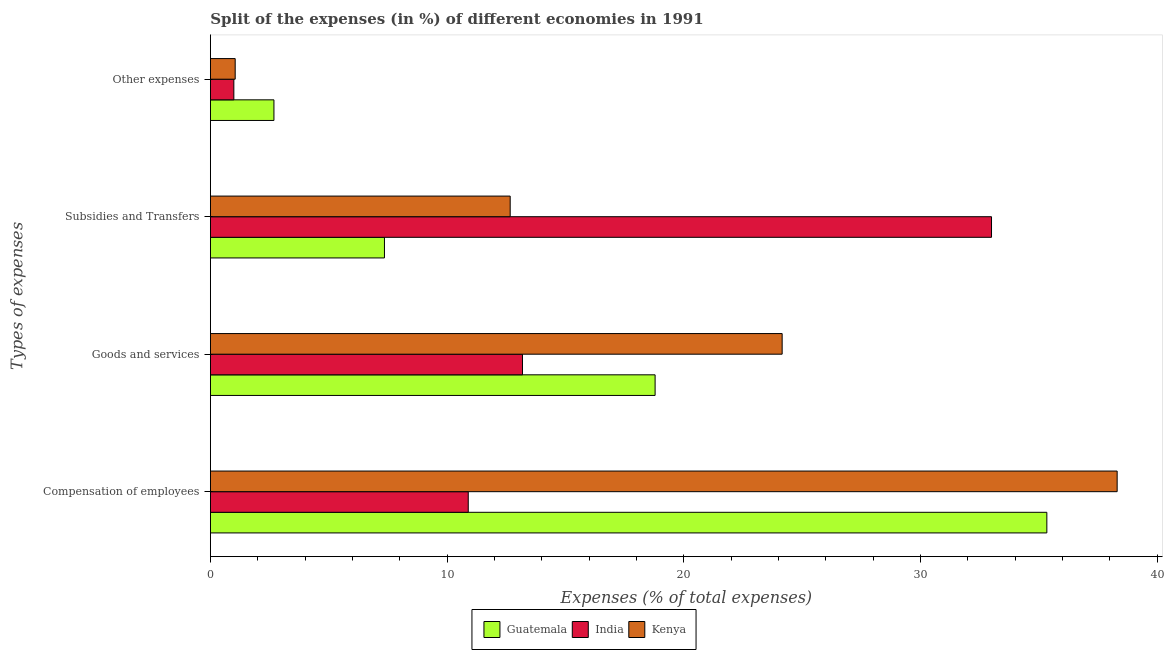Are the number of bars per tick equal to the number of legend labels?
Give a very brief answer. Yes. How many bars are there on the 3rd tick from the bottom?
Offer a very short reply. 3. What is the label of the 3rd group of bars from the top?
Provide a succinct answer. Goods and services. What is the percentage of amount spent on other expenses in India?
Offer a terse response. 0.99. Across all countries, what is the maximum percentage of amount spent on compensation of employees?
Your answer should be compact. 38.32. Across all countries, what is the minimum percentage of amount spent on goods and services?
Provide a succinct answer. 13.19. In which country was the percentage of amount spent on goods and services maximum?
Keep it short and to the point. Kenya. In which country was the percentage of amount spent on goods and services minimum?
Offer a very short reply. India. What is the total percentage of amount spent on other expenses in the graph?
Ensure brevity in your answer.  4.72. What is the difference between the percentage of amount spent on compensation of employees in Kenya and that in India?
Ensure brevity in your answer.  27.42. What is the difference between the percentage of amount spent on subsidies in Guatemala and the percentage of amount spent on other expenses in India?
Offer a very short reply. 6.36. What is the average percentage of amount spent on compensation of employees per country?
Provide a succinct answer. 28.19. What is the difference between the percentage of amount spent on goods and services and percentage of amount spent on compensation of employees in India?
Your response must be concise. 2.29. In how many countries, is the percentage of amount spent on compensation of employees greater than 10 %?
Give a very brief answer. 3. What is the ratio of the percentage of amount spent on goods and services in Kenya to that in India?
Make the answer very short. 1.83. Is the percentage of amount spent on goods and services in India less than that in Kenya?
Your response must be concise. Yes. What is the difference between the highest and the second highest percentage of amount spent on other expenses?
Your answer should be very brief. 1.64. What is the difference between the highest and the lowest percentage of amount spent on other expenses?
Ensure brevity in your answer.  1.69. Is it the case that in every country, the sum of the percentage of amount spent on goods and services and percentage of amount spent on subsidies is greater than the sum of percentage of amount spent on compensation of employees and percentage of amount spent on other expenses?
Provide a succinct answer. No. What does the 2nd bar from the top in Compensation of employees represents?
Make the answer very short. India. What does the 1st bar from the bottom in Other expenses represents?
Provide a succinct answer. Guatemala. How many countries are there in the graph?
Your answer should be very brief. 3. What is the difference between two consecutive major ticks on the X-axis?
Provide a short and direct response. 10. Are the values on the major ticks of X-axis written in scientific E-notation?
Ensure brevity in your answer.  No. How many legend labels are there?
Your answer should be very brief. 3. How are the legend labels stacked?
Keep it short and to the point. Horizontal. What is the title of the graph?
Offer a very short reply. Split of the expenses (in %) of different economies in 1991. Does "Lesotho" appear as one of the legend labels in the graph?
Make the answer very short. No. What is the label or title of the X-axis?
Ensure brevity in your answer.  Expenses (% of total expenses). What is the label or title of the Y-axis?
Your answer should be compact. Types of expenses. What is the Expenses (% of total expenses) of Guatemala in Compensation of employees?
Offer a very short reply. 35.34. What is the Expenses (% of total expenses) in India in Compensation of employees?
Make the answer very short. 10.9. What is the Expenses (% of total expenses) in Kenya in Compensation of employees?
Your answer should be compact. 38.32. What is the Expenses (% of total expenses) of Guatemala in Goods and services?
Your answer should be compact. 18.79. What is the Expenses (% of total expenses) of India in Goods and services?
Keep it short and to the point. 13.19. What is the Expenses (% of total expenses) of Kenya in Goods and services?
Offer a terse response. 24.16. What is the Expenses (% of total expenses) of Guatemala in Subsidies and Transfers?
Make the answer very short. 7.36. What is the Expenses (% of total expenses) of India in Subsidies and Transfers?
Keep it short and to the point. 33.01. What is the Expenses (% of total expenses) in Kenya in Subsidies and Transfers?
Provide a succinct answer. 12.67. What is the Expenses (% of total expenses) of Guatemala in Other expenses?
Give a very brief answer. 2.69. What is the Expenses (% of total expenses) of India in Other expenses?
Your answer should be compact. 0.99. What is the Expenses (% of total expenses) in Kenya in Other expenses?
Provide a succinct answer. 1.05. Across all Types of expenses, what is the maximum Expenses (% of total expenses) in Guatemala?
Make the answer very short. 35.34. Across all Types of expenses, what is the maximum Expenses (% of total expenses) of India?
Make the answer very short. 33.01. Across all Types of expenses, what is the maximum Expenses (% of total expenses) in Kenya?
Keep it short and to the point. 38.32. Across all Types of expenses, what is the minimum Expenses (% of total expenses) in Guatemala?
Offer a terse response. 2.69. Across all Types of expenses, what is the minimum Expenses (% of total expenses) of India?
Offer a very short reply. 0.99. Across all Types of expenses, what is the minimum Expenses (% of total expenses) in Kenya?
Your response must be concise. 1.05. What is the total Expenses (% of total expenses) of Guatemala in the graph?
Provide a succinct answer. 64.18. What is the total Expenses (% of total expenses) of India in the graph?
Provide a succinct answer. 58.08. What is the total Expenses (% of total expenses) of Kenya in the graph?
Provide a short and direct response. 76.19. What is the difference between the Expenses (% of total expenses) of Guatemala in Compensation of employees and that in Goods and services?
Offer a very short reply. 16.55. What is the difference between the Expenses (% of total expenses) in India in Compensation of employees and that in Goods and services?
Offer a very short reply. -2.29. What is the difference between the Expenses (% of total expenses) of Kenya in Compensation of employees and that in Goods and services?
Offer a very short reply. 14.16. What is the difference between the Expenses (% of total expenses) in Guatemala in Compensation of employees and that in Subsidies and Transfers?
Offer a very short reply. 27.99. What is the difference between the Expenses (% of total expenses) of India in Compensation of employees and that in Subsidies and Transfers?
Give a very brief answer. -22.11. What is the difference between the Expenses (% of total expenses) of Kenya in Compensation of employees and that in Subsidies and Transfers?
Offer a very short reply. 25.65. What is the difference between the Expenses (% of total expenses) in Guatemala in Compensation of employees and that in Other expenses?
Offer a terse response. 32.66. What is the difference between the Expenses (% of total expenses) in India in Compensation of employees and that in Other expenses?
Provide a short and direct response. 9.91. What is the difference between the Expenses (% of total expenses) in Kenya in Compensation of employees and that in Other expenses?
Offer a terse response. 37.27. What is the difference between the Expenses (% of total expenses) in Guatemala in Goods and services and that in Subsidies and Transfers?
Your answer should be compact. 11.44. What is the difference between the Expenses (% of total expenses) in India in Goods and services and that in Subsidies and Transfers?
Ensure brevity in your answer.  -19.82. What is the difference between the Expenses (% of total expenses) of Kenya in Goods and services and that in Subsidies and Transfers?
Ensure brevity in your answer.  11.49. What is the difference between the Expenses (% of total expenses) in Guatemala in Goods and services and that in Other expenses?
Your answer should be compact. 16.11. What is the difference between the Expenses (% of total expenses) in India in Goods and services and that in Other expenses?
Your answer should be very brief. 12.2. What is the difference between the Expenses (% of total expenses) in Kenya in Goods and services and that in Other expenses?
Offer a terse response. 23.11. What is the difference between the Expenses (% of total expenses) in Guatemala in Subsidies and Transfers and that in Other expenses?
Your response must be concise. 4.67. What is the difference between the Expenses (% of total expenses) in India in Subsidies and Transfers and that in Other expenses?
Provide a short and direct response. 32.02. What is the difference between the Expenses (% of total expenses) of Kenya in Subsidies and Transfers and that in Other expenses?
Your response must be concise. 11.62. What is the difference between the Expenses (% of total expenses) in Guatemala in Compensation of employees and the Expenses (% of total expenses) in India in Goods and services?
Offer a very short reply. 22.16. What is the difference between the Expenses (% of total expenses) in Guatemala in Compensation of employees and the Expenses (% of total expenses) in Kenya in Goods and services?
Your answer should be very brief. 11.18. What is the difference between the Expenses (% of total expenses) of India in Compensation of employees and the Expenses (% of total expenses) of Kenya in Goods and services?
Make the answer very short. -13.26. What is the difference between the Expenses (% of total expenses) in Guatemala in Compensation of employees and the Expenses (% of total expenses) in India in Subsidies and Transfers?
Keep it short and to the point. 2.34. What is the difference between the Expenses (% of total expenses) of Guatemala in Compensation of employees and the Expenses (% of total expenses) of Kenya in Subsidies and Transfers?
Offer a very short reply. 22.68. What is the difference between the Expenses (% of total expenses) in India in Compensation of employees and the Expenses (% of total expenses) in Kenya in Subsidies and Transfers?
Offer a terse response. -1.77. What is the difference between the Expenses (% of total expenses) of Guatemala in Compensation of employees and the Expenses (% of total expenses) of India in Other expenses?
Give a very brief answer. 34.35. What is the difference between the Expenses (% of total expenses) in Guatemala in Compensation of employees and the Expenses (% of total expenses) in Kenya in Other expenses?
Offer a very short reply. 34.3. What is the difference between the Expenses (% of total expenses) in India in Compensation of employees and the Expenses (% of total expenses) in Kenya in Other expenses?
Your answer should be compact. 9.85. What is the difference between the Expenses (% of total expenses) in Guatemala in Goods and services and the Expenses (% of total expenses) in India in Subsidies and Transfers?
Keep it short and to the point. -14.22. What is the difference between the Expenses (% of total expenses) of Guatemala in Goods and services and the Expenses (% of total expenses) of Kenya in Subsidies and Transfers?
Make the answer very short. 6.12. What is the difference between the Expenses (% of total expenses) of India in Goods and services and the Expenses (% of total expenses) of Kenya in Subsidies and Transfers?
Give a very brief answer. 0.52. What is the difference between the Expenses (% of total expenses) of Guatemala in Goods and services and the Expenses (% of total expenses) of India in Other expenses?
Provide a short and direct response. 17.8. What is the difference between the Expenses (% of total expenses) of Guatemala in Goods and services and the Expenses (% of total expenses) of Kenya in Other expenses?
Give a very brief answer. 17.74. What is the difference between the Expenses (% of total expenses) of India in Goods and services and the Expenses (% of total expenses) of Kenya in Other expenses?
Your response must be concise. 12.14. What is the difference between the Expenses (% of total expenses) in Guatemala in Subsidies and Transfers and the Expenses (% of total expenses) in India in Other expenses?
Keep it short and to the point. 6.36. What is the difference between the Expenses (% of total expenses) in Guatemala in Subsidies and Transfers and the Expenses (% of total expenses) in Kenya in Other expenses?
Ensure brevity in your answer.  6.31. What is the difference between the Expenses (% of total expenses) in India in Subsidies and Transfers and the Expenses (% of total expenses) in Kenya in Other expenses?
Your answer should be very brief. 31.96. What is the average Expenses (% of total expenses) in Guatemala per Types of expenses?
Provide a succinct answer. 16.04. What is the average Expenses (% of total expenses) of India per Types of expenses?
Your answer should be compact. 14.52. What is the average Expenses (% of total expenses) in Kenya per Types of expenses?
Ensure brevity in your answer.  19.05. What is the difference between the Expenses (% of total expenses) in Guatemala and Expenses (% of total expenses) in India in Compensation of employees?
Make the answer very short. 24.45. What is the difference between the Expenses (% of total expenses) of Guatemala and Expenses (% of total expenses) of Kenya in Compensation of employees?
Provide a short and direct response. -2.97. What is the difference between the Expenses (% of total expenses) of India and Expenses (% of total expenses) of Kenya in Compensation of employees?
Your answer should be very brief. -27.42. What is the difference between the Expenses (% of total expenses) of Guatemala and Expenses (% of total expenses) of India in Goods and services?
Your answer should be compact. 5.6. What is the difference between the Expenses (% of total expenses) of Guatemala and Expenses (% of total expenses) of Kenya in Goods and services?
Ensure brevity in your answer.  -5.37. What is the difference between the Expenses (% of total expenses) in India and Expenses (% of total expenses) in Kenya in Goods and services?
Your answer should be compact. -10.97. What is the difference between the Expenses (% of total expenses) of Guatemala and Expenses (% of total expenses) of India in Subsidies and Transfers?
Give a very brief answer. -25.65. What is the difference between the Expenses (% of total expenses) in Guatemala and Expenses (% of total expenses) in Kenya in Subsidies and Transfers?
Provide a short and direct response. -5.31. What is the difference between the Expenses (% of total expenses) of India and Expenses (% of total expenses) of Kenya in Subsidies and Transfers?
Offer a very short reply. 20.34. What is the difference between the Expenses (% of total expenses) in Guatemala and Expenses (% of total expenses) in India in Other expenses?
Your response must be concise. 1.69. What is the difference between the Expenses (% of total expenses) of Guatemala and Expenses (% of total expenses) of Kenya in Other expenses?
Make the answer very short. 1.64. What is the difference between the Expenses (% of total expenses) of India and Expenses (% of total expenses) of Kenya in Other expenses?
Provide a succinct answer. -0.06. What is the ratio of the Expenses (% of total expenses) in Guatemala in Compensation of employees to that in Goods and services?
Give a very brief answer. 1.88. What is the ratio of the Expenses (% of total expenses) in India in Compensation of employees to that in Goods and services?
Your answer should be compact. 0.83. What is the ratio of the Expenses (% of total expenses) in Kenya in Compensation of employees to that in Goods and services?
Your response must be concise. 1.59. What is the ratio of the Expenses (% of total expenses) in Guatemala in Compensation of employees to that in Subsidies and Transfers?
Ensure brevity in your answer.  4.81. What is the ratio of the Expenses (% of total expenses) in India in Compensation of employees to that in Subsidies and Transfers?
Ensure brevity in your answer.  0.33. What is the ratio of the Expenses (% of total expenses) in Kenya in Compensation of employees to that in Subsidies and Transfers?
Provide a succinct answer. 3.02. What is the ratio of the Expenses (% of total expenses) of Guatemala in Compensation of employees to that in Other expenses?
Give a very brief answer. 13.16. What is the ratio of the Expenses (% of total expenses) in India in Compensation of employees to that in Other expenses?
Keep it short and to the point. 10.99. What is the ratio of the Expenses (% of total expenses) in Kenya in Compensation of employees to that in Other expenses?
Give a very brief answer. 36.56. What is the ratio of the Expenses (% of total expenses) of Guatemala in Goods and services to that in Subsidies and Transfers?
Offer a terse response. 2.55. What is the ratio of the Expenses (% of total expenses) of India in Goods and services to that in Subsidies and Transfers?
Make the answer very short. 0.4. What is the ratio of the Expenses (% of total expenses) in Kenya in Goods and services to that in Subsidies and Transfers?
Offer a very short reply. 1.91. What is the ratio of the Expenses (% of total expenses) of Guatemala in Goods and services to that in Other expenses?
Your answer should be very brief. 7. What is the ratio of the Expenses (% of total expenses) of India in Goods and services to that in Other expenses?
Make the answer very short. 13.3. What is the ratio of the Expenses (% of total expenses) in Kenya in Goods and services to that in Other expenses?
Provide a succinct answer. 23.05. What is the ratio of the Expenses (% of total expenses) in Guatemala in Subsidies and Transfers to that in Other expenses?
Provide a succinct answer. 2.74. What is the ratio of the Expenses (% of total expenses) of India in Subsidies and Transfers to that in Other expenses?
Offer a terse response. 33.3. What is the ratio of the Expenses (% of total expenses) of Kenya in Subsidies and Transfers to that in Other expenses?
Your answer should be very brief. 12.09. What is the difference between the highest and the second highest Expenses (% of total expenses) in Guatemala?
Offer a terse response. 16.55. What is the difference between the highest and the second highest Expenses (% of total expenses) in India?
Your response must be concise. 19.82. What is the difference between the highest and the second highest Expenses (% of total expenses) in Kenya?
Your answer should be compact. 14.16. What is the difference between the highest and the lowest Expenses (% of total expenses) in Guatemala?
Ensure brevity in your answer.  32.66. What is the difference between the highest and the lowest Expenses (% of total expenses) in India?
Your answer should be compact. 32.02. What is the difference between the highest and the lowest Expenses (% of total expenses) in Kenya?
Your answer should be very brief. 37.27. 